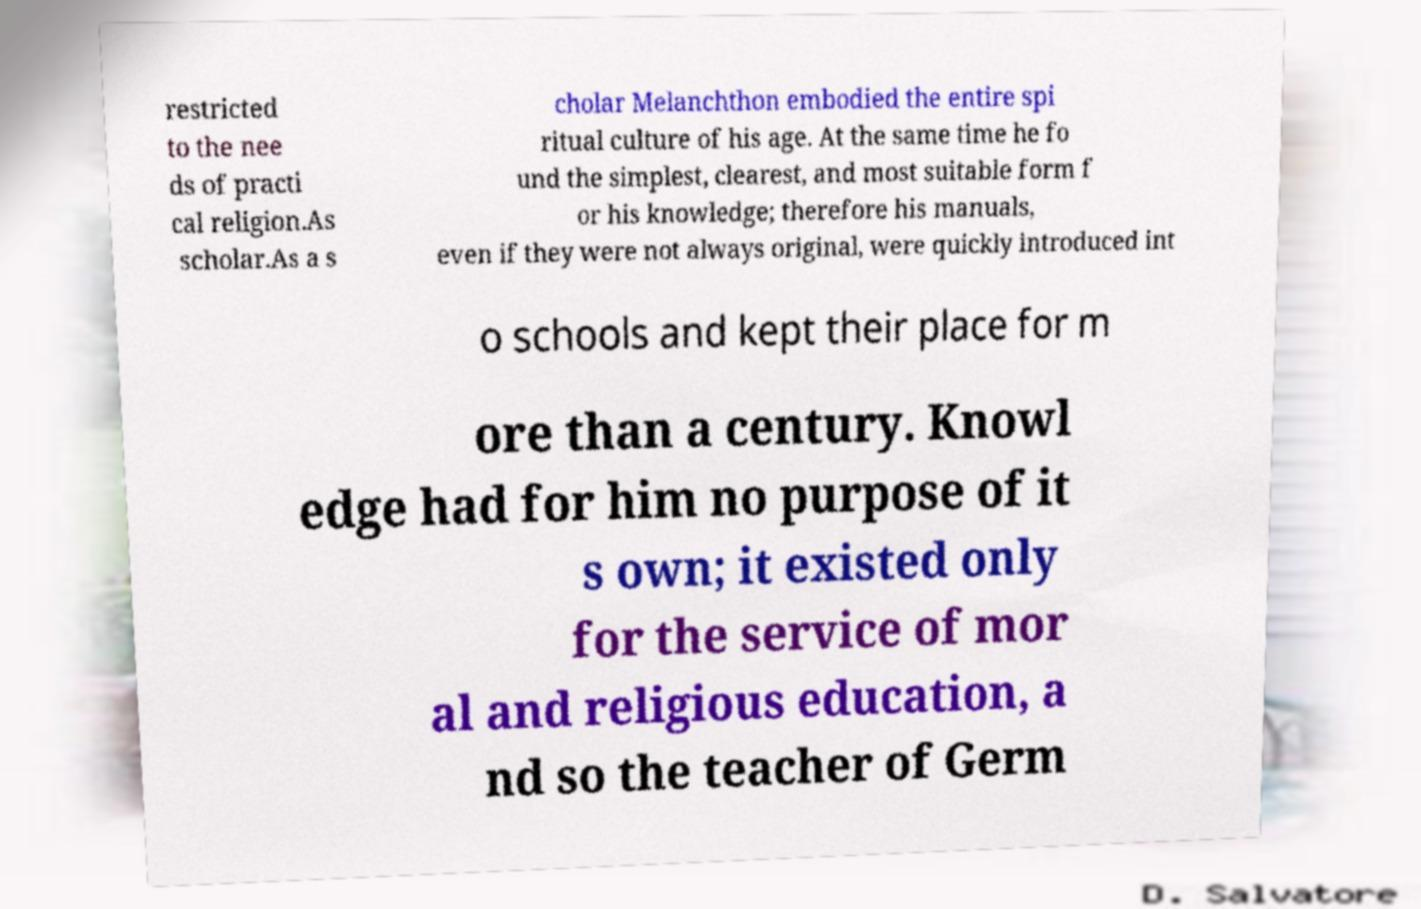There's text embedded in this image that I need extracted. Can you transcribe it verbatim? restricted to the nee ds of practi cal religion.As scholar.As a s cholar Melanchthon embodied the entire spi ritual culture of his age. At the same time he fo und the simplest, clearest, and most suitable form f or his knowledge; therefore his manuals, even if they were not always original, were quickly introduced int o schools and kept their place for m ore than a century. Knowl edge had for him no purpose of it s own; it existed only for the service of mor al and religious education, a nd so the teacher of Germ 